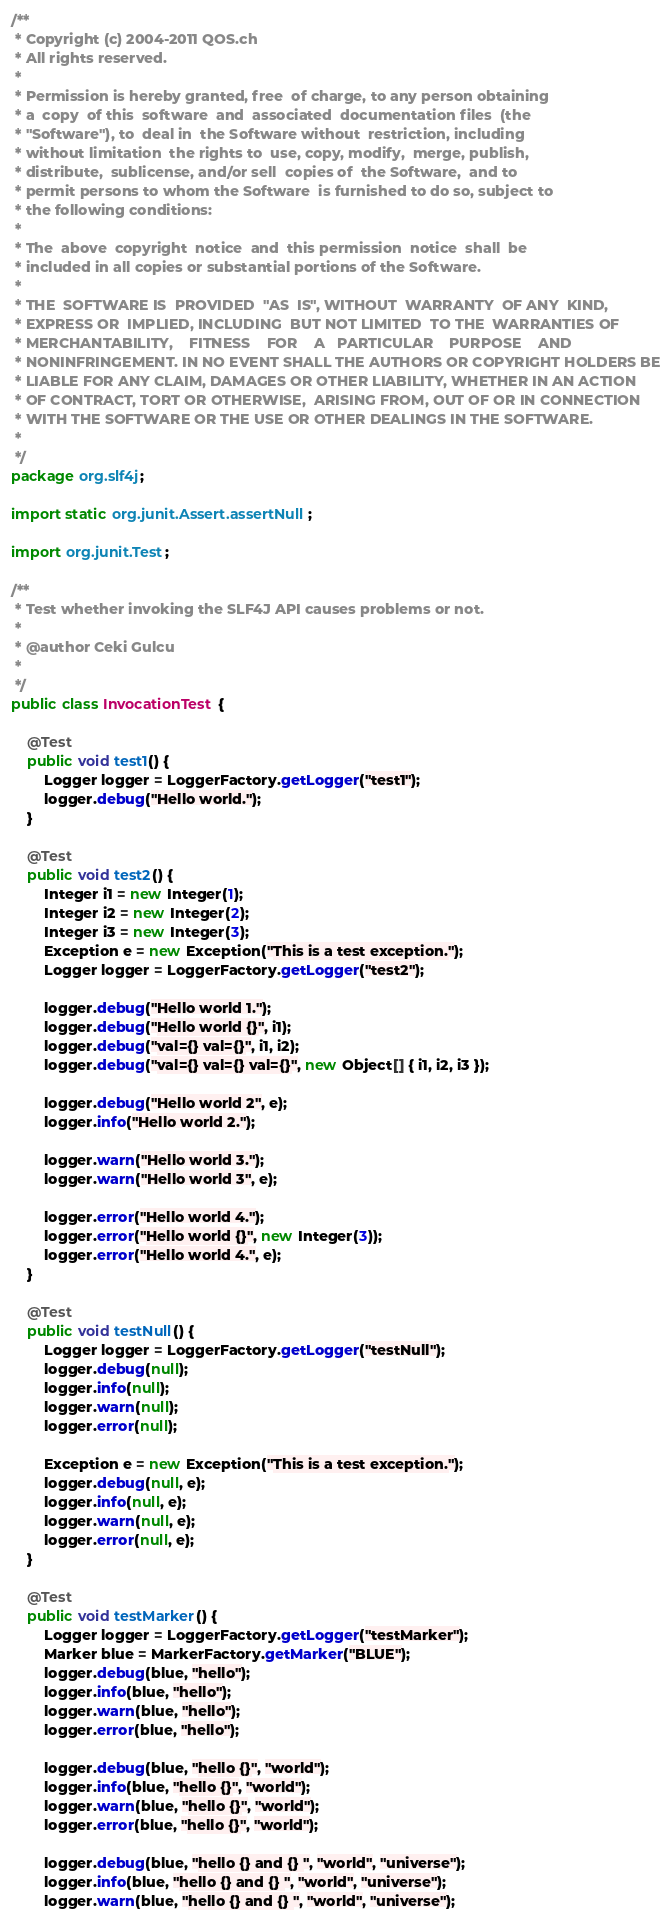Convert code to text. <code><loc_0><loc_0><loc_500><loc_500><_Java_>/**
 * Copyright (c) 2004-2011 QOS.ch
 * All rights reserved.
 *
 * Permission is hereby granted, free  of charge, to any person obtaining
 * a  copy  of this  software  and  associated  documentation files  (the
 * "Software"), to  deal in  the Software without  restriction, including
 * without limitation  the rights to  use, copy, modify,  merge, publish,
 * distribute,  sublicense, and/or sell  copies of  the Software,  and to
 * permit persons to whom the Software  is furnished to do so, subject to
 * the following conditions:
 *
 * The  above  copyright  notice  and  this permission  notice  shall  be
 * included in all copies or substantial portions of the Software.
 *
 * THE  SOFTWARE IS  PROVIDED  "AS  IS", WITHOUT  WARRANTY  OF ANY  KIND,
 * EXPRESS OR  IMPLIED, INCLUDING  BUT NOT LIMITED  TO THE  WARRANTIES OF
 * MERCHANTABILITY,    FITNESS    FOR    A   PARTICULAR    PURPOSE    AND
 * NONINFRINGEMENT. IN NO EVENT SHALL THE AUTHORS OR COPYRIGHT HOLDERS BE
 * LIABLE FOR ANY CLAIM, DAMAGES OR OTHER LIABILITY, WHETHER IN AN ACTION
 * OF CONTRACT, TORT OR OTHERWISE,  ARISING FROM, OUT OF OR IN CONNECTION
 * WITH THE SOFTWARE OR THE USE OR OTHER DEALINGS IN THE SOFTWARE.
 *
 */
package org.slf4j;

import static org.junit.Assert.assertNull;

import org.junit.Test;

/**
 * Test whether invoking the SLF4J API causes problems or not.
 * 
 * @author Ceki Gulcu
 *
 */
public class InvocationTest {

    @Test
    public void test1() {
        Logger logger = LoggerFactory.getLogger("test1");
        logger.debug("Hello world.");
    }

    @Test
    public void test2() {
        Integer i1 = new Integer(1);
        Integer i2 = new Integer(2);
        Integer i3 = new Integer(3);
        Exception e = new Exception("This is a test exception.");
        Logger logger = LoggerFactory.getLogger("test2");

        logger.debug("Hello world 1.");
        logger.debug("Hello world {}", i1);
        logger.debug("val={} val={}", i1, i2);
        logger.debug("val={} val={} val={}", new Object[] { i1, i2, i3 });

        logger.debug("Hello world 2", e);
        logger.info("Hello world 2.");

        logger.warn("Hello world 3.");
        logger.warn("Hello world 3", e);

        logger.error("Hello world 4.");
        logger.error("Hello world {}", new Integer(3));
        logger.error("Hello world 4.", e);
    }

    @Test
    public void testNull() {
        Logger logger = LoggerFactory.getLogger("testNull");
        logger.debug(null);
        logger.info(null);
        logger.warn(null);
        logger.error(null);

        Exception e = new Exception("This is a test exception.");
        logger.debug(null, e);
        logger.info(null, e);
        logger.warn(null, e);
        logger.error(null, e);
    }

    @Test
    public void testMarker() {
        Logger logger = LoggerFactory.getLogger("testMarker");
        Marker blue = MarkerFactory.getMarker("BLUE");
        logger.debug(blue, "hello");
        logger.info(blue, "hello");
        logger.warn(blue, "hello");
        logger.error(blue, "hello");

        logger.debug(blue, "hello {}", "world");
        logger.info(blue, "hello {}", "world");
        logger.warn(blue, "hello {}", "world");
        logger.error(blue, "hello {}", "world");

        logger.debug(blue, "hello {} and {} ", "world", "universe");
        logger.info(blue, "hello {} and {} ", "world", "universe");
        logger.warn(blue, "hello {} and {} ", "world", "universe");</code> 